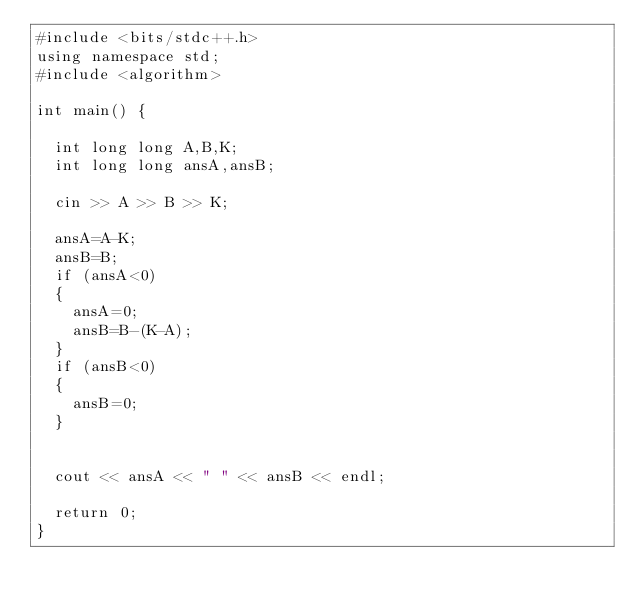Convert code to text. <code><loc_0><loc_0><loc_500><loc_500><_C++_>#include <bits/stdc++.h>
using namespace std;
#include <algorithm>
 
int main() {
 
  int long long A,B,K;
  int long long ansA,ansB;
  
  cin >> A >> B >> K;
 
  ansA=A-K;
  ansB=B;
  if (ansA<0)
  {
    ansA=0;
    ansB=B-(K-A);
  }
  if (ansB<0)
  {
    ansB=0;
  }
  
 
  cout << ansA << " " << ansB << endl;
  
  return 0;
}</code> 